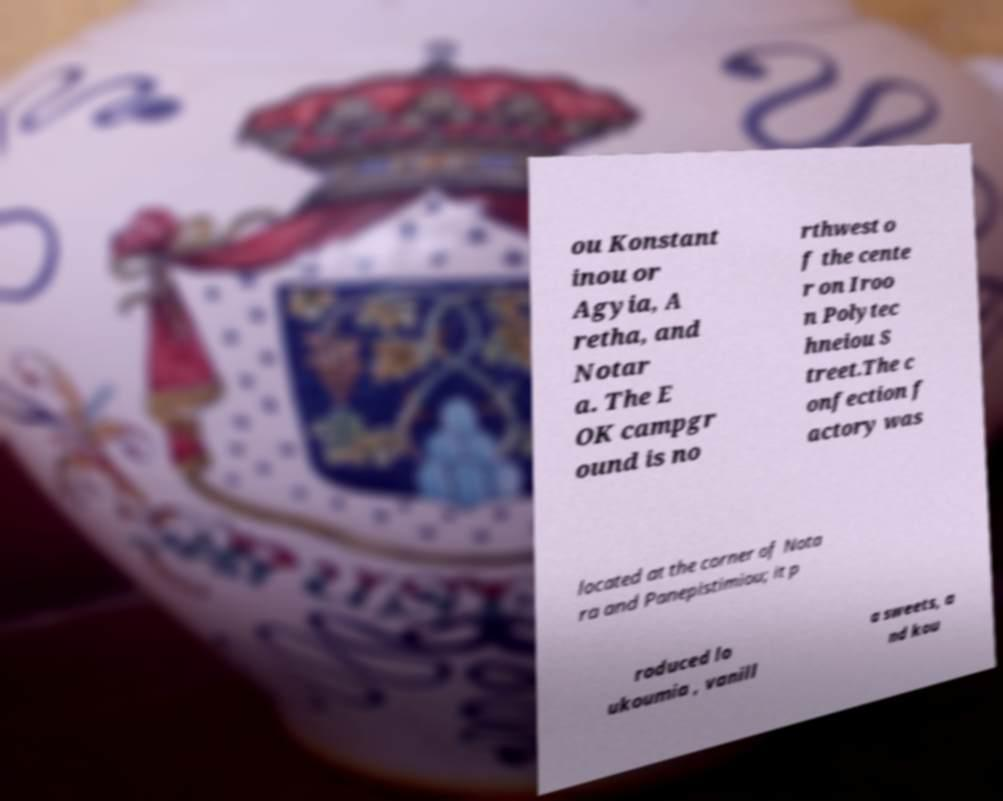There's text embedded in this image that I need extracted. Can you transcribe it verbatim? ou Konstant inou or Agyia, A retha, and Notar a. The E OK campgr ound is no rthwest o f the cente r on Iroo n Polytec hneiou S treet.The c onfection f actory was located at the corner of Nota ra and Panepistimiou; it p roduced lo ukoumia , vanill a sweets, a nd kou 